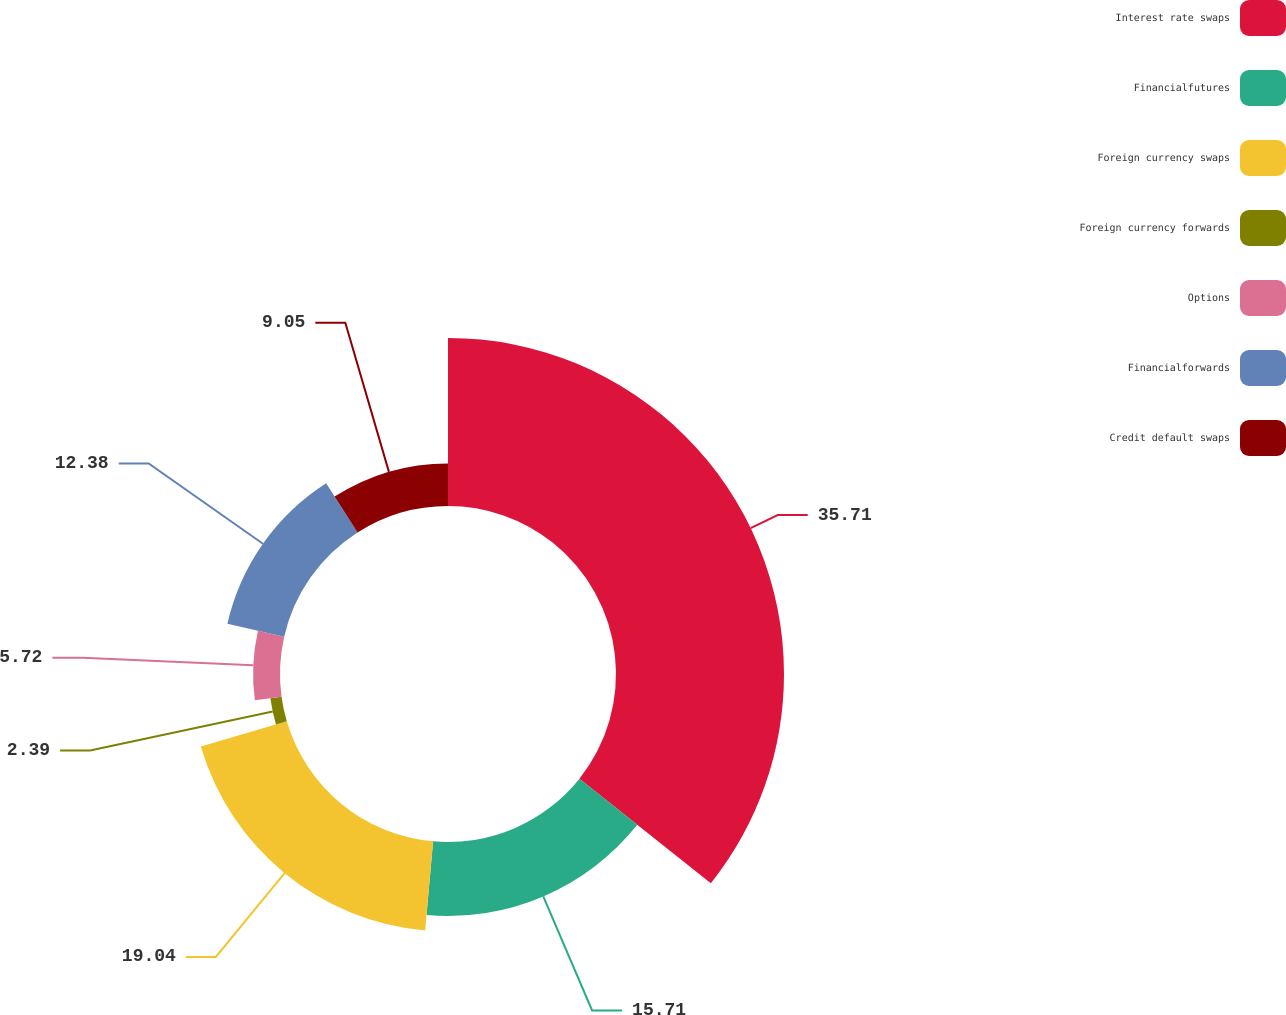Convert chart to OTSL. <chart><loc_0><loc_0><loc_500><loc_500><pie_chart><fcel>Interest rate swaps<fcel>Financialfutures<fcel>Foreign currency swaps<fcel>Foreign currency forwards<fcel>Options<fcel>Financialforwards<fcel>Credit default swaps<nl><fcel>35.7%<fcel>15.71%<fcel>19.04%<fcel>2.39%<fcel>5.72%<fcel>12.38%<fcel>9.05%<nl></chart> 